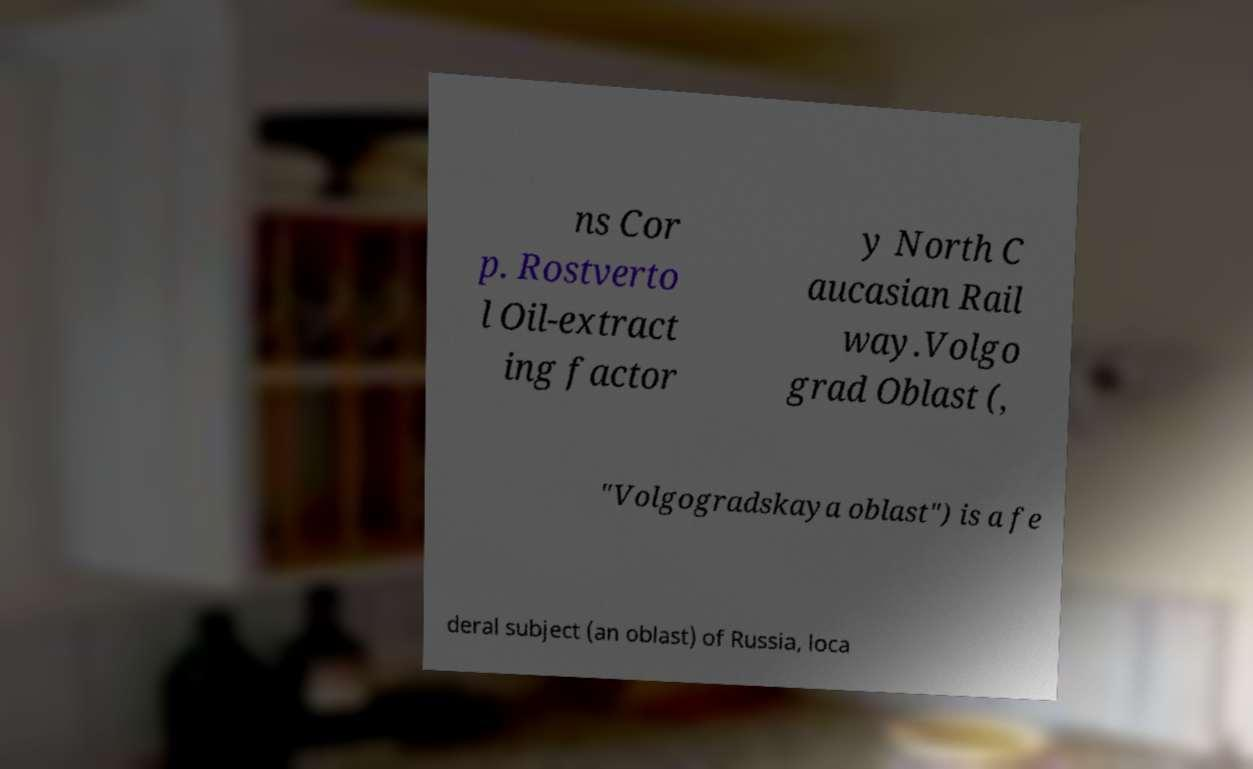Please identify and transcribe the text found in this image. ns Cor p. Rostverto l Oil-extract ing factor y North C aucasian Rail way.Volgo grad Oblast (, "Volgogradskaya oblast") is a fe deral subject (an oblast) of Russia, loca 